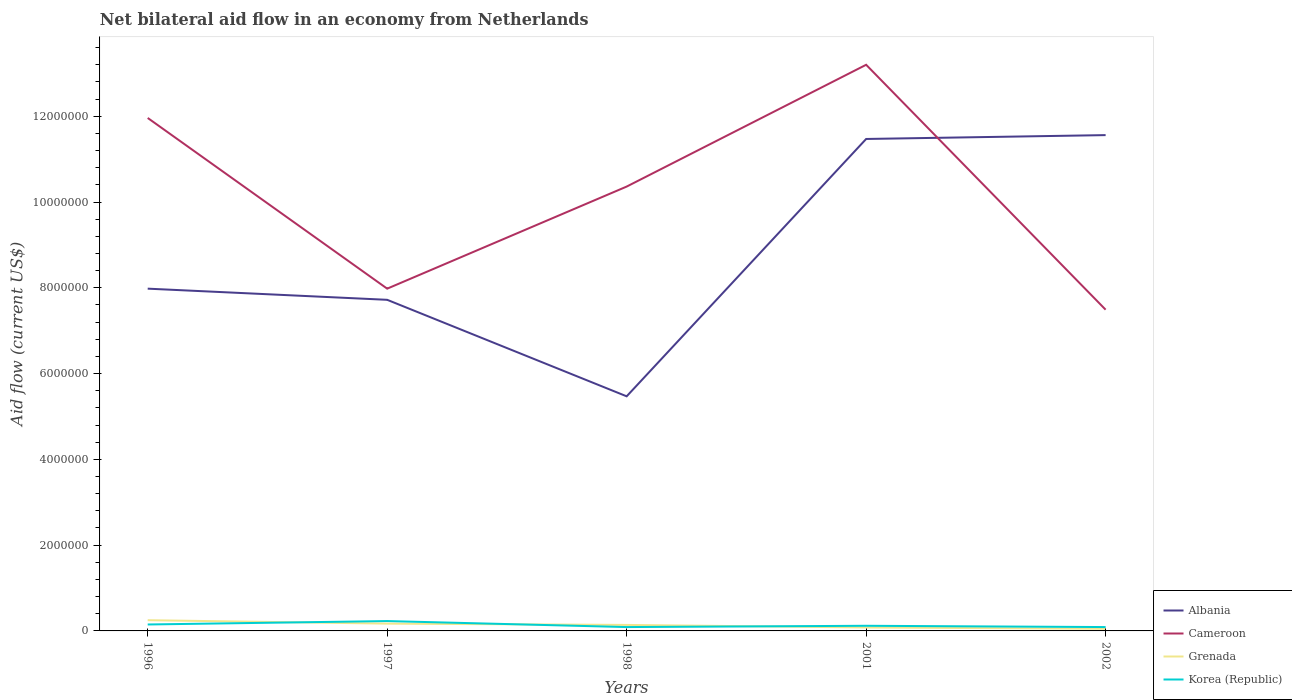How many different coloured lines are there?
Give a very brief answer. 4. Does the line corresponding to Cameroon intersect with the line corresponding to Albania?
Provide a succinct answer. Yes. Across all years, what is the maximum net bilateral aid flow in Albania?
Your answer should be very brief. 5.47e+06. In which year was the net bilateral aid flow in Korea (Republic) maximum?
Make the answer very short. 1998. What is the total net bilateral aid flow in Grenada in the graph?
Make the answer very short. 6.00e+04. What is the difference between the highest and the second highest net bilateral aid flow in Grenada?
Your answer should be very brief. 2.00e+05. How many lines are there?
Make the answer very short. 4. How many legend labels are there?
Give a very brief answer. 4. How are the legend labels stacked?
Your answer should be compact. Vertical. What is the title of the graph?
Provide a short and direct response. Net bilateral aid flow in an economy from Netherlands. Does "Mauritius" appear as one of the legend labels in the graph?
Offer a terse response. No. What is the label or title of the Y-axis?
Keep it short and to the point. Aid flow (current US$). What is the Aid flow (current US$) of Albania in 1996?
Your answer should be very brief. 7.98e+06. What is the Aid flow (current US$) in Cameroon in 1996?
Your answer should be compact. 1.20e+07. What is the Aid flow (current US$) in Albania in 1997?
Ensure brevity in your answer.  7.72e+06. What is the Aid flow (current US$) of Cameroon in 1997?
Keep it short and to the point. 7.98e+06. What is the Aid flow (current US$) of Korea (Republic) in 1997?
Your response must be concise. 2.30e+05. What is the Aid flow (current US$) of Albania in 1998?
Give a very brief answer. 5.47e+06. What is the Aid flow (current US$) of Cameroon in 1998?
Your response must be concise. 1.04e+07. What is the Aid flow (current US$) of Albania in 2001?
Your answer should be very brief. 1.15e+07. What is the Aid flow (current US$) in Cameroon in 2001?
Provide a short and direct response. 1.32e+07. What is the Aid flow (current US$) in Korea (Republic) in 2001?
Your response must be concise. 1.20e+05. What is the Aid flow (current US$) in Albania in 2002?
Your answer should be very brief. 1.16e+07. What is the Aid flow (current US$) in Cameroon in 2002?
Your answer should be compact. 7.49e+06. Across all years, what is the maximum Aid flow (current US$) of Albania?
Keep it short and to the point. 1.16e+07. Across all years, what is the maximum Aid flow (current US$) of Cameroon?
Ensure brevity in your answer.  1.32e+07. Across all years, what is the maximum Aid flow (current US$) in Grenada?
Offer a very short reply. 2.50e+05. Across all years, what is the minimum Aid flow (current US$) in Albania?
Your answer should be very brief. 5.47e+06. Across all years, what is the minimum Aid flow (current US$) of Cameroon?
Make the answer very short. 7.49e+06. What is the total Aid flow (current US$) in Albania in the graph?
Provide a succinct answer. 4.42e+07. What is the total Aid flow (current US$) in Cameroon in the graph?
Provide a short and direct response. 5.10e+07. What is the total Aid flow (current US$) of Grenada in the graph?
Ensure brevity in your answer.  6.90e+05. What is the total Aid flow (current US$) in Korea (Republic) in the graph?
Offer a terse response. 6.80e+05. What is the difference between the Aid flow (current US$) of Albania in 1996 and that in 1997?
Offer a very short reply. 2.60e+05. What is the difference between the Aid flow (current US$) in Cameroon in 1996 and that in 1997?
Offer a very short reply. 3.98e+06. What is the difference between the Aid flow (current US$) of Albania in 1996 and that in 1998?
Provide a short and direct response. 2.51e+06. What is the difference between the Aid flow (current US$) of Cameroon in 1996 and that in 1998?
Your answer should be very brief. 1.60e+06. What is the difference between the Aid flow (current US$) in Albania in 1996 and that in 2001?
Provide a short and direct response. -3.49e+06. What is the difference between the Aid flow (current US$) of Cameroon in 1996 and that in 2001?
Offer a terse response. -1.24e+06. What is the difference between the Aid flow (current US$) in Albania in 1996 and that in 2002?
Offer a very short reply. -3.58e+06. What is the difference between the Aid flow (current US$) of Cameroon in 1996 and that in 2002?
Your answer should be very brief. 4.47e+06. What is the difference between the Aid flow (current US$) of Grenada in 1996 and that in 2002?
Your answer should be very brief. 2.00e+05. What is the difference between the Aid flow (current US$) of Korea (Republic) in 1996 and that in 2002?
Your response must be concise. 6.00e+04. What is the difference between the Aid flow (current US$) of Albania in 1997 and that in 1998?
Keep it short and to the point. 2.25e+06. What is the difference between the Aid flow (current US$) in Cameroon in 1997 and that in 1998?
Give a very brief answer. -2.38e+06. What is the difference between the Aid flow (current US$) in Grenada in 1997 and that in 1998?
Your answer should be compact. 3.00e+04. What is the difference between the Aid flow (current US$) of Korea (Republic) in 1997 and that in 1998?
Ensure brevity in your answer.  1.40e+05. What is the difference between the Aid flow (current US$) in Albania in 1997 and that in 2001?
Your answer should be compact. -3.75e+06. What is the difference between the Aid flow (current US$) in Cameroon in 1997 and that in 2001?
Ensure brevity in your answer.  -5.22e+06. What is the difference between the Aid flow (current US$) in Grenada in 1997 and that in 2001?
Keep it short and to the point. 9.00e+04. What is the difference between the Aid flow (current US$) of Korea (Republic) in 1997 and that in 2001?
Offer a terse response. 1.10e+05. What is the difference between the Aid flow (current US$) of Albania in 1997 and that in 2002?
Your answer should be very brief. -3.84e+06. What is the difference between the Aid flow (current US$) of Grenada in 1997 and that in 2002?
Provide a short and direct response. 1.20e+05. What is the difference between the Aid flow (current US$) of Korea (Republic) in 1997 and that in 2002?
Keep it short and to the point. 1.40e+05. What is the difference between the Aid flow (current US$) of Albania in 1998 and that in 2001?
Offer a terse response. -6.00e+06. What is the difference between the Aid flow (current US$) of Cameroon in 1998 and that in 2001?
Your answer should be very brief. -2.84e+06. What is the difference between the Aid flow (current US$) in Korea (Republic) in 1998 and that in 2001?
Provide a succinct answer. -3.00e+04. What is the difference between the Aid flow (current US$) in Albania in 1998 and that in 2002?
Make the answer very short. -6.09e+06. What is the difference between the Aid flow (current US$) of Cameroon in 1998 and that in 2002?
Ensure brevity in your answer.  2.87e+06. What is the difference between the Aid flow (current US$) of Grenada in 1998 and that in 2002?
Give a very brief answer. 9.00e+04. What is the difference between the Aid flow (current US$) of Korea (Republic) in 1998 and that in 2002?
Offer a terse response. 0. What is the difference between the Aid flow (current US$) of Cameroon in 2001 and that in 2002?
Your answer should be compact. 5.71e+06. What is the difference between the Aid flow (current US$) in Albania in 1996 and the Aid flow (current US$) in Cameroon in 1997?
Your answer should be very brief. 0. What is the difference between the Aid flow (current US$) in Albania in 1996 and the Aid flow (current US$) in Grenada in 1997?
Offer a terse response. 7.81e+06. What is the difference between the Aid flow (current US$) of Albania in 1996 and the Aid flow (current US$) of Korea (Republic) in 1997?
Offer a very short reply. 7.75e+06. What is the difference between the Aid flow (current US$) in Cameroon in 1996 and the Aid flow (current US$) in Grenada in 1997?
Your response must be concise. 1.18e+07. What is the difference between the Aid flow (current US$) of Cameroon in 1996 and the Aid flow (current US$) of Korea (Republic) in 1997?
Your response must be concise. 1.17e+07. What is the difference between the Aid flow (current US$) in Albania in 1996 and the Aid flow (current US$) in Cameroon in 1998?
Make the answer very short. -2.38e+06. What is the difference between the Aid flow (current US$) of Albania in 1996 and the Aid flow (current US$) of Grenada in 1998?
Offer a terse response. 7.84e+06. What is the difference between the Aid flow (current US$) in Albania in 1996 and the Aid flow (current US$) in Korea (Republic) in 1998?
Ensure brevity in your answer.  7.89e+06. What is the difference between the Aid flow (current US$) of Cameroon in 1996 and the Aid flow (current US$) of Grenada in 1998?
Your answer should be compact. 1.18e+07. What is the difference between the Aid flow (current US$) in Cameroon in 1996 and the Aid flow (current US$) in Korea (Republic) in 1998?
Give a very brief answer. 1.19e+07. What is the difference between the Aid flow (current US$) of Grenada in 1996 and the Aid flow (current US$) of Korea (Republic) in 1998?
Give a very brief answer. 1.60e+05. What is the difference between the Aid flow (current US$) of Albania in 1996 and the Aid flow (current US$) of Cameroon in 2001?
Ensure brevity in your answer.  -5.22e+06. What is the difference between the Aid flow (current US$) in Albania in 1996 and the Aid flow (current US$) in Grenada in 2001?
Ensure brevity in your answer.  7.90e+06. What is the difference between the Aid flow (current US$) of Albania in 1996 and the Aid flow (current US$) of Korea (Republic) in 2001?
Your answer should be very brief. 7.86e+06. What is the difference between the Aid flow (current US$) in Cameroon in 1996 and the Aid flow (current US$) in Grenada in 2001?
Provide a succinct answer. 1.19e+07. What is the difference between the Aid flow (current US$) of Cameroon in 1996 and the Aid flow (current US$) of Korea (Republic) in 2001?
Your response must be concise. 1.18e+07. What is the difference between the Aid flow (current US$) of Albania in 1996 and the Aid flow (current US$) of Grenada in 2002?
Give a very brief answer. 7.93e+06. What is the difference between the Aid flow (current US$) of Albania in 1996 and the Aid flow (current US$) of Korea (Republic) in 2002?
Your response must be concise. 7.89e+06. What is the difference between the Aid flow (current US$) in Cameroon in 1996 and the Aid flow (current US$) in Grenada in 2002?
Your response must be concise. 1.19e+07. What is the difference between the Aid flow (current US$) of Cameroon in 1996 and the Aid flow (current US$) of Korea (Republic) in 2002?
Your answer should be very brief. 1.19e+07. What is the difference between the Aid flow (current US$) in Albania in 1997 and the Aid flow (current US$) in Cameroon in 1998?
Make the answer very short. -2.64e+06. What is the difference between the Aid flow (current US$) of Albania in 1997 and the Aid flow (current US$) of Grenada in 1998?
Ensure brevity in your answer.  7.58e+06. What is the difference between the Aid flow (current US$) in Albania in 1997 and the Aid flow (current US$) in Korea (Republic) in 1998?
Offer a terse response. 7.63e+06. What is the difference between the Aid flow (current US$) in Cameroon in 1997 and the Aid flow (current US$) in Grenada in 1998?
Keep it short and to the point. 7.84e+06. What is the difference between the Aid flow (current US$) of Cameroon in 1997 and the Aid flow (current US$) of Korea (Republic) in 1998?
Offer a terse response. 7.89e+06. What is the difference between the Aid flow (current US$) of Grenada in 1997 and the Aid flow (current US$) of Korea (Republic) in 1998?
Your response must be concise. 8.00e+04. What is the difference between the Aid flow (current US$) of Albania in 1997 and the Aid flow (current US$) of Cameroon in 2001?
Give a very brief answer. -5.48e+06. What is the difference between the Aid flow (current US$) of Albania in 1997 and the Aid flow (current US$) of Grenada in 2001?
Your answer should be compact. 7.64e+06. What is the difference between the Aid flow (current US$) in Albania in 1997 and the Aid flow (current US$) in Korea (Republic) in 2001?
Offer a very short reply. 7.60e+06. What is the difference between the Aid flow (current US$) of Cameroon in 1997 and the Aid flow (current US$) of Grenada in 2001?
Your response must be concise. 7.90e+06. What is the difference between the Aid flow (current US$) of Cameroon in 1997 and the Aid flow (current US$) of Korea (Republic) in 2001?
Provide a short and direct response. 7.86e+06. What is the difference between the Aid flow (current US$) of Albania in 1997 and the Aid flow (current US$) of Grenada in 2002?
Offer a very short reply. 7.67e+06. What is the difference between the Aid flow (current US$) of Albania in 1997 and the Aid flow (current US$) of Korea (Republic) in 2002?
Your response must be concise. 7.63e+06. What is the difference between the Aid flow (current US$) of Cameroon in 1997 and the Aid flow (current US$) of Grenada in 2002?
Your answer should be very brief. 7.93e+06. What is the difference between the Aid flow (current US$) of Cameroon in 1997 and the Aid flow (current US$) of Korea (Republic) in 2002?
Offer a terse response. 7.89e+06. What is the difference between the Aid flow (current US$) in Albania in 1998 and the Aid flow (current US$) in Cameroon in 2001?
Keep it short and to the point. -7.73e+06. What is the difference between the Aid flow (current US$) in Albania in 1998 and the Aid flow (current US$) in Grenada in 2001?
Ensure brevity in your answer.  5.39e+06. What is the difference between the Aid flow (current US$) in Albania in 1998 and the Aid flow (current US$) in Korea (Republic) in 2001?
Offer a terse response. 5.35e+06. What is the difference between the Aid flow (current US$) of Cameroon in 1998 and the Aid flow (current US$) of Grenada in 2001?
Your response must be concise. 1.03e+07. What is the difference between the Aid flow (current US$) of Cameroon in 1998 and the Aid flow (current US$) of Korea (Republic) in 2001?
Offer a terse response. 1.02e+07. What is the difference between the Aid flow (current US$) in Grenada in 1998 and the Aid flow (current US$) in Korea (Republic) in 2001?
Provide a succinct answer. 2.00e+04. What is the difference between the Aid flow (current US$) in Albania in 1998 and the Aid flow (current US$) in Cameroon in 2002?
Provide a short and direct response. -2.02e+06. What is the difference between the Aid flow (current US$) of Albania in 1998 and the Aid flow (current US$) of Grenada in 2002?
Make the answer very short. 5.42e+06. What is the difference between the Aid flow (current US$) in Albania in 1998 and the Aid flow (current US$) in Korea (Republic) in 2002?
Provide a short and direct response. 5.38e+06. What is the difference between the Aid flow (current US$) in Cameroon in 1998 and the Aid flow (current US$) in Grenada in 2002?
Keep it short and to the point. 1.03e+07. What is the difference between the Aid flow (current US$) of Cameroon in 1998 and the Aid flow (current US$) of Korea (Republic) in 2002?
Ensure brevity in your answer.  1.03e+07. What is the difference between the Aid flow (current US$) in Grenada in 1998 and the Aid flow (current US$) in Korea (Republic) in 2002?
Offer a terse response. 5.00e+04. What is the difference between the Aid flow (current US$) of Albania in 2001 and the Aid flow (current US$) of Cameroon in 2002?
Keep it short and to the point. 3.98e+06. What is the difference between the Aid flow (current US$) in Albania in 2001 and the Aid flow (current US$) in Grenada in 2002?
Your answer should be very brief. 1.14e+07. What is the difference between the Aid flow (current US$) in Albania in 2001 and the Aid flow (current US$) in Korea (Republic) in 2002?
Keep it short and to the point. 1.14e+07. What is the difference between the Aid flow (current US$) of Cameroon in 2001 and the Aid flow (current US$) of Grenada in 2002?
Offer a very short reply. 1.32e+07. What is the difference between the Aid flow (current US$) in Cameroon in 2001 and the Aid flow (current US$) in Korea (Republic) in 2002?
Ensure brevity in your answer.  1.31e+07. What is the difference between the Aid flow (current US$) of Grenada in 2001 and the Aid flow (current US$) of Korea (Republic) in 2002?
Your answer should be very brief. -10000. What is the average Aid flow (current US$) in Albania per year?
Your answer should be very brief. 8.84e+06. What is the average Aid flow (current US$) in Cameroon per year?
Provide a succinct answer. 1.02e+07. What is the average Aid flow (current US$) in Grenada per year?
Your response must be concise. 1.38e+05. What is the average Aid flow (current US$) of Korea (Republic) per year?
Your answer should be very brief. 1.36e+05. In the year 1996, what is the difference between the Aid flow (current US$) of Albania and Aid flow (current US$) of Cameroon?
Offer a terse response. -3.98e+06. In the year 1996, what is the difference between the Aid flow (current US$) of Albania and Aid flow (current US$) of Grenada?
Make the answer very short. 7.73e+06. In the year 1996, what is the difference between the Aid flow (current US$) of Albania and Aid flow (current US$) of Korea (Republic)?
Provide a succinct answer. 7.83e+06. In the year 1996, what is the difference between the Aid flow (current US$) of Cameroon and Aid flow (current US$) of Grenada?
Ensure brevity in your answer.  1.17e+07. In the year 1996, what is the difference between the Aid flow (current US$) of Cameroon and Aid flow (current US$) of Korea (Republic)?
Your answer should be very brief. 1.18e+07. In the year 1996, what is the difference between the Aid flow (current US$) of Grenada and Aid flow (current US$) of Korea (Republic)?
Offer a terse response. 1.00e+05. In the year 1997, what is the difference between the Aid flow (current US$) of Albania and Aid flow (current US$) of Cameroon?
Provide a succinct answer. -2.60e+05. In the year 1997, what is the difference between the Aid flow (current US$) in Albania and Aid flow (current US$) in Grenada?
Keep it short and to the point. 7.55e+06. In the year 1997, what is the difference between the Aid flow (current US$) of Albania and Aid flow (current US$) of Korea (Republic)?
Provide a succinct answer. 7.49e+06. In the year 1997, what is the difference between the Aid flow (current US$) in Cameroon and Aid flow (current US$) in Grenada?
Your answer should be very brief. 7.81e+06. In the year 1997, what is the difference between the Aid flow (current US$) in Cameroon and Aid flow (current US$) in Korea (Republic)?
Provide a succinct answer. 7.75e+06. In the year 1998, what is the difference between the Aid flow (current US$) in Albania and Aid flow (current US$) in Cameroon?
Provide a short and direct response. -4.89e+06. In the year 1998, what is the difference between the Aid flow (current US$) in Albania and Aid flow (current US$) in Grenada?
Your answer should be compact. 5.33e+06. In the year 1998, what is the difference between the Aid flow (current US$) in Albania and Aid flow (current US$) in Korea (Republic)?
Your answer should be compact. 5.38e+06. In the year 1998, what is the difference between the Aid flow (current US$) in Cameroon and Aid flow (current US$) in Grenada?
Give a very brief answer. 1.02e+07. In the year 1998, what is the difference between the Aid flow (current US$) of Cameroon and Aid flow (current US$) of Korea (Republic)?
Offer a very short reply. 1.03e+07. In the year 2001, what is the difference between the Aid flow (current US$) in Albania and Aid flow (current US$) in Cameroon?
Your answer should be very brief. -1.73e+06. In the year 2001, what is the difference between the Aid flow (current US$) in Albania and Aid flow (current US$) in Grenada?
Provide a short and direct response. 1.14e+07. In the year 2001, what is the difference between the Aid flow (current US$) of Albania and Aid flow (current US$) of Korea (Republic)?
Offer a terse response. 1.14e+07. In the year 2001, what is the difference between the Aid flow (current US$) in Cameroon and Aid flow (current US$) in Grenada?
Your response must be concise. 1.31e+07. In the year 2001, what is the difference between the Aid flow (current US$) in Cameroon and Aid flow (current US$) in Korea (Republic)?
Offer a terse response. 1.31e+07. In the year 2001, what is the difference between the Aid flow (current US$) of Grenada and Aid flow (current US$) of Korea (Republic)?
Make the answer very short. -4.00e+04. In the year 2002, what is the difference between the Aid flow (current US$) in Albania and Aid flow (current US$) in Cameroon?
Provide a succinct answer. 4.07e+06. In the year 2002, what is the difference between the Aid flow (current US$) of Albania and Aid flow (current US$) of Grenada?
Provide a succinct answer. 1.15e+07. In the year 2002, what is the difference between the Aid flow (current US$) in Albania and Aid flow (current US$) in Korea (Republic)?
Make the answer very short. 1.15e+07. In the year 2002, what is the difference between the Aid flow (current US$) in Cameroon and Aid flow (current US$) in Grenada?
Offer a very short reply. 7.44e+06. In the year 2002, what is the difference between the Aid flow (current US$) in Cameroon and Aid flow (current US$) in Korea (Republic)?
Make the answer very short. 7.40e+06. What is the ratio of the Aid flow (current US$) in Albania in 1996 to that in 1997?
Ensure brevity in your answer.  1.03. What is the ratio of the Aid flow (current US$) in Cameroon in 1996 to that in 1997?
Make the answer very short. 1.5. What is the ratio of the Aid flow (current US$) in Grenada in 1996 to that in 1997?
Keep it short and to the point. 1.47. What is the ratio of the Aid flow (current US$) in Korea (Republic) in 1996 to that in 1997?
Provide a succinct answer. 0.65. What is the ratio of the Aid flow (current US$) of Albania in 1996 to that in 1998?
Your answer should be very brief. 1.46. What is the ratio of the Aid flow (current US$) of Cameroon in 1996 to that in 1998?
Make the answer very short. 1.15. What is the ratio of the Aid flow (current US$) in Grenada in 1996 to that in 1998?
Give a very brief answer. 1.79. What is the ratio of the Aid flow (current US$) of Korea (Republic) in 1996 to that in 1998?
Your response must be concise. 1.67. What is the ratio of the Aid flow (current US$) in Albania in 1996 to that in 2001?
Provide a short and direct response. 0.7. What is the ratio of the Aid flow (current US$) of Cameroon in 1996 to that in 2001?
Give a very brief answer. 0.91. What is the ratio of the Aid flow (current US$) in Grenada in 1996 to that in 2001?
Your response must be concise. 3.12. What is the ratio of the Aid flow (current US$) in Albania in 1996 to that in 2002?
Your answer should be compact. 0.69. What is the ratio of the Aid flow (current US$) in Cameroon in 1996 to that in 2002?
Provide a short and direct response. 1.6. What is the ratio of the Aid flow (current US$) of Albania in 1997 to that in 1998?
Offer a very short reply. 1.41. What is the ratio of the Aid flow (current US$) in Cameroon in 1997 to that in 1998?
Provide a short and direct response. 0.77. What is the ratio of the Aid flow (current US$) in Grenada in 1997 to that in 1998?
Provide a succinct answer. 1.21. What is the ratio of the Aid flow (current US$) in Korea (Republic) in 1997 to that in 1998?
Ensure brevity in your answer.  2.56. What is the ratio of the Aid flow (current US$) of Albania in 1997 to that in 2001?
Your answer should be compact. 0.67. What is the ratio of the Aid flow (current US$) in Cameroon in 1997 to that in 2001?
Your response must be concise. 0.6. What is the ratio of the Aid flow (current US$) in Grenada in 1997 to that in 2001?
Your answer should be very brief. 2.12. What is the ratio of the Aid flow (current US$) of Korea (Republic) in 1997 to that in 2001?
Ensure brevity in your answer.  1.92. What is the ratio of the Aid flow (current US$) in Albania in 1997 to that in 2002?
Keep it short and to the point. 0.67. What is the ratio of the Aid flow (current US$) in Cameroon in 1997 to that in 2002?
Provide a short and direct response. 1.07. What is the ratio of the Aid flow (current US$) of Korea (Republic) in 1997 to that in 2002?
Keep it short and to the point. 2.56. What is the ratio of the Aid flow (current US$) in Albania in 1998 to that in 2001?
Your answer should be compact. 0.48. What is the ratio of the Aid flow (current US$) of Cameroon in 1998 to that in 2001?
Keep it short and to the point. 0.78. What is the ratio of the Aid flow (current US$) of Albania in 1998 to that in 2002?
Keep it short and to the point. 0.47. What is the ratio of the Aid flow (current US$) in Cameroon in 1998 to that in 2002?
Make the answer very short. 1.38. What is the ratio of the Aid flow (current US$) of Grenada in 1998 to that in 2002?
Provide a succinct answer. 2.8. What is the ratio of the Aid flow (current US$) of Korea (Republic) in 1998 to that in 2002?
Provide a succinct answer. 1. What is the ratio of the Aid flow (current US$) in Cameroon in 2001 to that in 2002?
Offer a terse response. 1.76. What is the difference between the highest and the second highest Aid flow (current US$) in Albania?
Offer a terse response. 9.00e+04. What is the difference between the highest and the second highest Aid flow (current US$) in Cameroon?
Keep it short and to the point. 1.24e+06. What is the difference between the highest and the second highest Aid flow (current US$) in Korea (Republic)?
Ensure brevity in your answer.  8.00e+04. What is the difference between the highest and the lowest Aid flow (current US$) in Albania?
Ensure brevity in your answer.  6.09e+06. What is the difference between the highest and the lowest Aid flow (current US$) in Cameroon?
Give a very brief answer. 5.71e+06. What is the difference between the highest and the lowest Aid flow (current US$) of Grenada?
Provide a short and direct response. 2.00e+05. What is the difference between the highest and the lowest Aid flow (current US$) in Korea (Republic)?
Ensure brevity in your answer.  1.40e+05. 